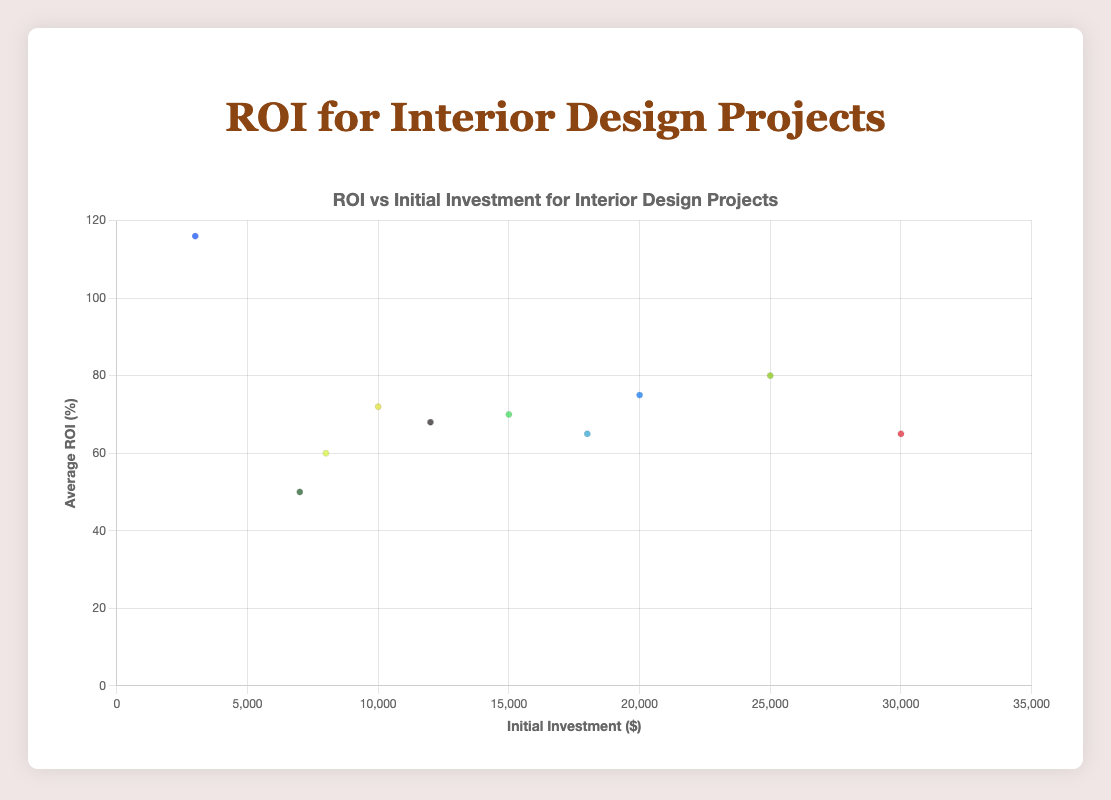What is the project with the highest average ROI percentage? To find the project with the highest average ROI percentage, visually identify the data point that reaches the highest on the Y-axis, which represents the ROI percentage. In the figure, "Attic Insulation" has the highest point at 116%.
Answer: Attic Insulation Which project requires the most initial investment? To determine this, look for the data point furthest to the right on the X-axis, which represents initial investment in dollars. The furthest point to the right is "Garage Addition" with $30,000.
Answer: Garage Addition What is the total increase in average sale value for all projects combined? Sum the average sale increase for each project: 20000 + 10000 + 15000 + 12000 + 5000 + 3500 + 19500 + 8100 + 7200 + 3480 = 103780.
Answer: $103,780 Which project has the longest time to ROI and what is it? Identify the data point with the largest circle radius (circle size is proportional to time to ROI). The largest circle corresponds to the "Garage Addition" project with 7 years.
Answer: Garage Addition, 7 years How does the average ROI percentage of "Roof Replacement" compare to "Window Replacement"? Locate the data points for "Roof Replacement" and "Window Replacement" and look at their positions along the Y-axis (ROI percentage). "Roof Replacement" has 68% ROI, and "Window Replacement" has 72% ROI, so "Window Replacement" has a higher ROI percentage.
Answer: Window Replacement has a higher ROI Which project yields an average ROI percentage greater than 100% and what is it? Look for the data point above the 100% mark on the Y-axis. "Attic Insulation" has an average ROI percentage of 116%, which is above 100%.
Answer: Attic Insulation What is the average initial investment for all projects? Sum all initial investments and divide by the number of projects: (25000 + 15000 + 20000 + 18000 + 8000 + 7000 + 30000 + 12000 + 10000 + 3000) / 10 = 168,000 / 10 = $16,800.
Answer: $16,800 Which project has the most balanced combination of initial investment and ROI percentage? Identify a data point close to the median of initial investment (X-axis) and median ROI percentage (Y-axis). "Window Replacement" has an initial investment of $10,000 (close to median) and an ROI percentage of 72% (close to median).
Answer: Window Replacement 